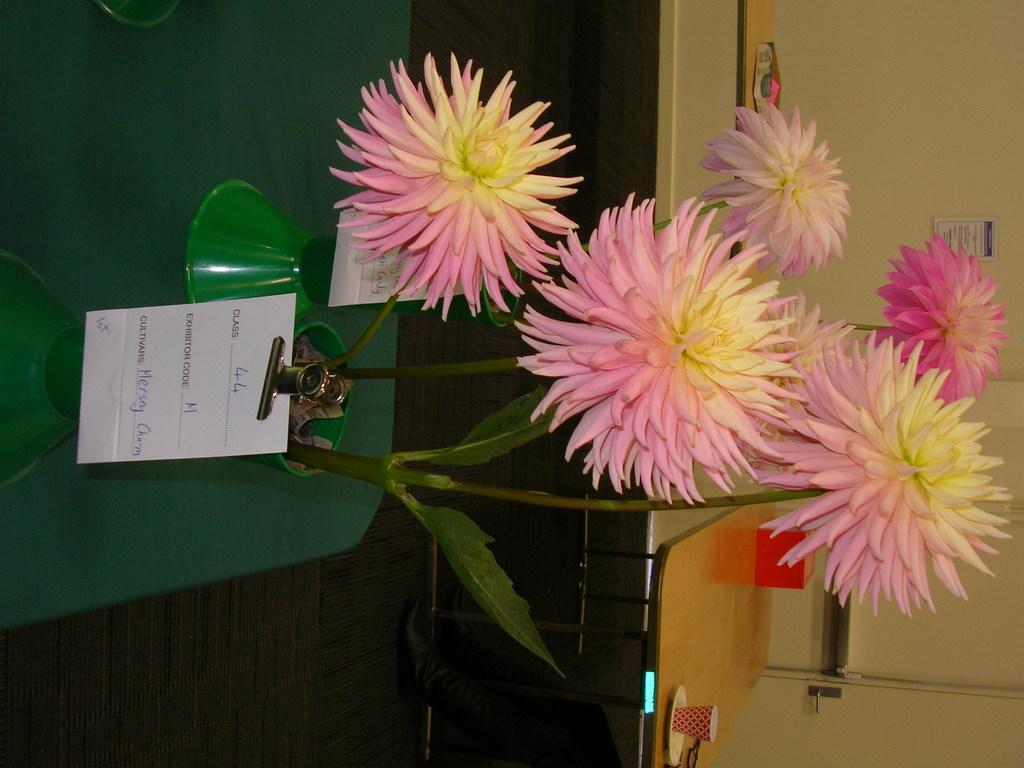How would you summarize this image in a sentence or two? In this image there is a table, on that table there is a flower vase, in the background there is another table, on that table there is a cup and a box and there is a wall. 